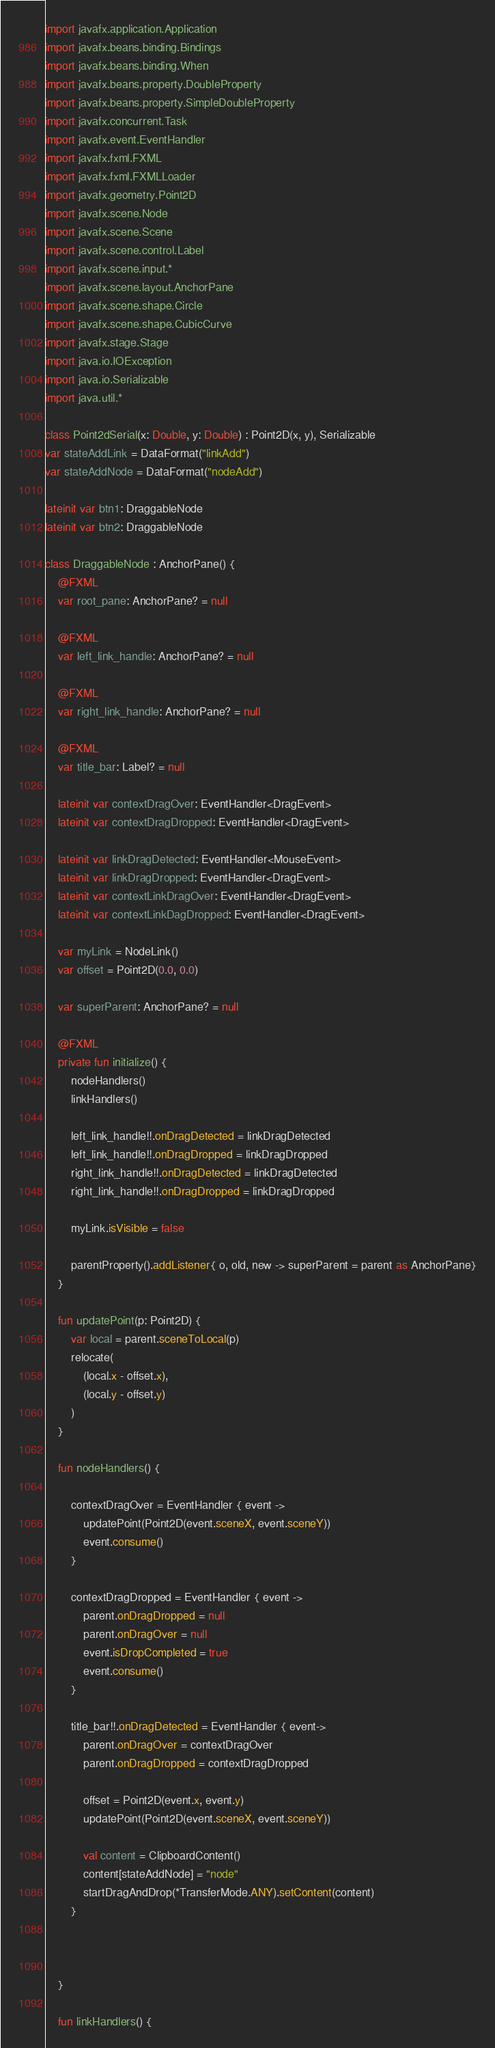<code> <loc_0><loc_0><loc_500><loc_500><_Kotlin_>import javafx.application.Application
import javafx.beans.binding.Bindings
import javafx.beans.binding.When
import javafx.beans.property.DoubleProperty
import javafx.beans.property.SimpleDoubleProperty
import javafx.concurrent.Task
import javafx.event.EventHandler
import javafx.fxml.FXML
import javafx.fxml.FXMLLoader
import javafx.geometry.Point2D
import javafx.scene.Node
import javafx.scene.Scene
import javafx.scene.control.Label
import javafx.scene.input.*
import javafx.scene.layout.AnchorPane
import javafx.scene.shape.Circle
import javafx.scene.shape.CubicCurve
import javafx.stage.Stage
import java.io.IOException
import java.io.Serializable
import java.util.*

class Point2dSerial(x: Double, y: Double) : Point2D(x, y), Serializable
var stateAddLink = DataFormat("linkAdd")
var stateAddNode = DataFormat("nodeAdd")

lateinit var btn1: DraggableNode
lateinit var btn2: DraggableNode

class DraggableNode : AnchorPane() {
    @FXML
    var root_pane: AnchorPane? = null

    @FXML
    var left_link_handle: AnchorPane? = null

    @FXML
    var right_link_handle: AnchorPane? = null

    @FXML
    var title_bar: Label? = null

    lateinit var contextDragOver: EventHandler<DragEvent>
    lateinit var contextDragDropped: EventHandler<DragEvent>

    lateinit var linkDragDetected: EventHandler<MouseEvent>
    lateinit var linkDragDropped: EventHandler<DragEvent>
    lateinit var contextLinkDragOver: EventHandler<DragEvent>
    lateinit var contextLinkDagDropped: EventHandler<DragEvent>

    var myLink = NodeLink()
    var offset = Point2D(0.0, 0.0)

    var superParent: AnchorPane? = null

    @FXML
    private fun initialize() {
        nodeHandlers()
        linkHandlers()

        left_link_handle!!.onDragDetected = linkDragDetected
        left_link_handle!!.onDragDropped = linkDragDropped
        right_link_handle!!.onDragDetected = linkDragDetected
        right_link_handle!!.onDragDropped = linkDragDropped

        myLink.isVisible = false

        parentProperty().addListener{ o, old, new -> superParent = parent as AnchorPane}
    }

    fun updatePoint(p: Point2D) {
        var local = parent.sceneToLocal(p)
        relocate(
            (local.x - offset.x),
            (local.y - offset.y)
        )
    }

    fun nodeHandlers() {

        contextDragOver = EventHandler { event ->
            updatePoint(Point2D(event.sceneX, event.sceneY))
            event.consume()
        }

        contextDragDropped = EventHandler { event ->
            parent.onDragDropped = null
            parent.onDragOver = null
            event.isDropCompleted = true
            event.consume()
        }

        title_bar!!.onDragDetected = EventHandler { event->
            parent.onDragOver = contextDragOver
            parent.onDragDropped = contextDragDropped

            offset = Point2D(event.x, event.y)
            updatePoint(Point2D(event.sceneX, event.sceneY))

            val content = ClipboardContent()
            content[stateAddNode] = "node"
            startDragAndDrop(*TransferMode.ANY).setContent(content)
        }



    }

    fun linkHandlers() {
</code> 